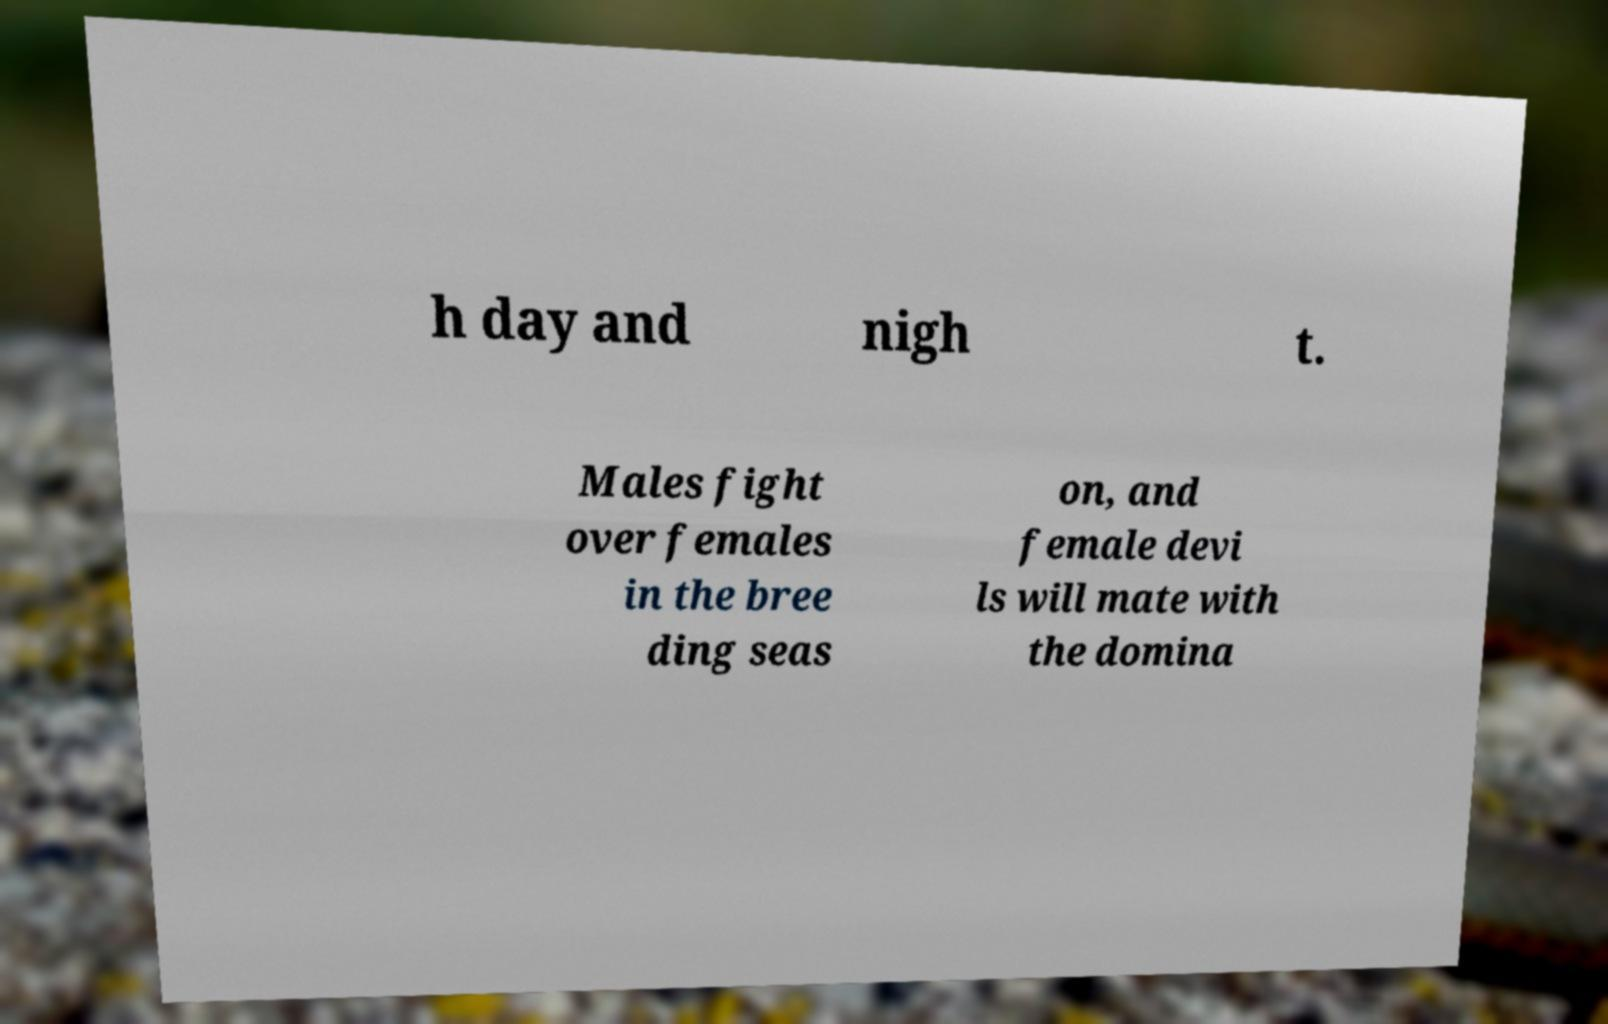Could you extract and type out the text from this image? h day and nigh t. Males fight over females in the bree ding seas on, and female devi ls will mate with the domina 